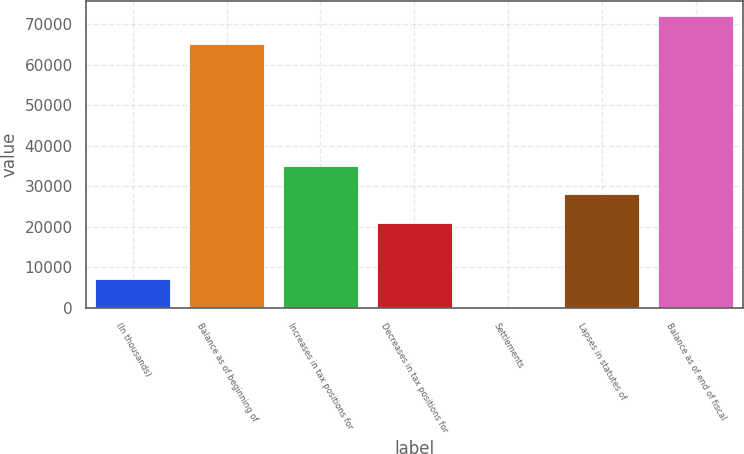<chart> <loc_0><loc_0><loc_500><loc_500><bar_chart><fcel>(In thousands)<fcel>Balance as of beginning of<fcel>Increases in tax positions for<fcel>Decreases in tax positions for<fcel>Settlements<fcel>Lapses in statutes of<fcel>Balance as of end of fiscal<nl><fcel>7035.3<fcel>65038<fcel>35000.5<fcel>21017.9<fcel>44<fcel>28009.2<fcel>72029.3<nl></chart> 